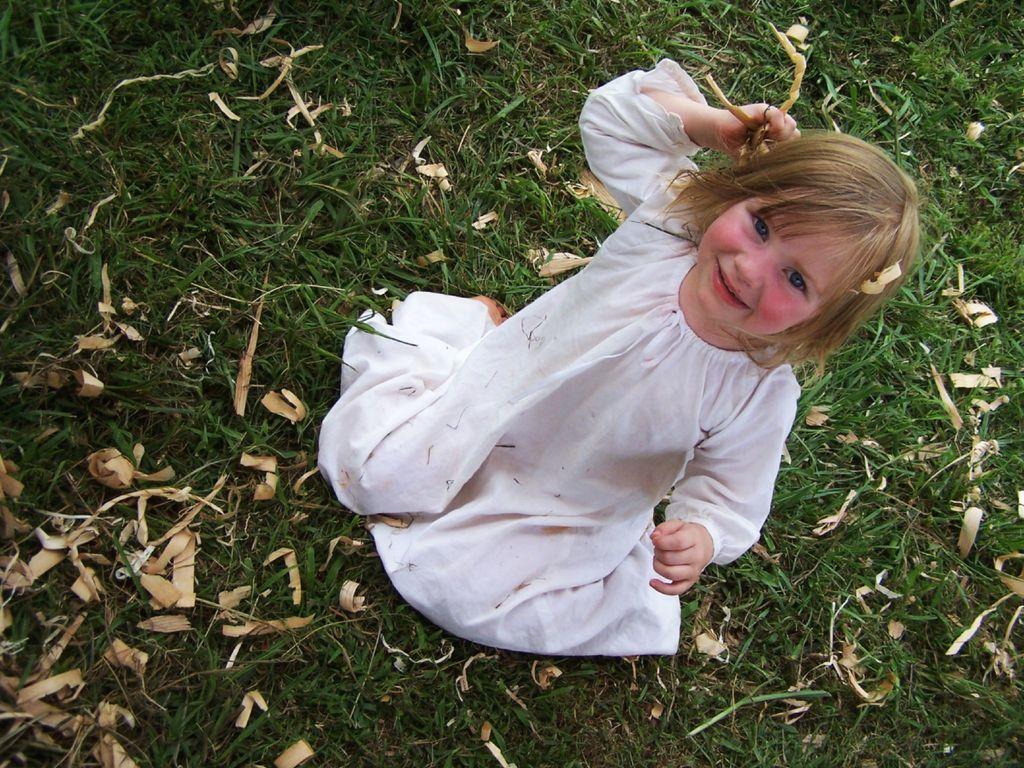Could you give a brief overview of what you see in this image? In this image in the center there is a girl sitting and smiling and there's grass on the ground and there are dry leaves. 